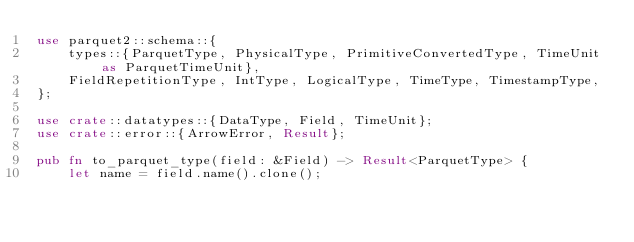Convert code to text. <code><loc_0><loc_0><loc_500><loc_500><_Rust_>use parquet2::schema::{
    types::{ParquetType, PhysicalType, PrimitiveConvertedType, TimeUnit as ParquetTimeUnit},
    FieldRepetitionType, IntType, LogicalType, TimeType, TimestampType,
};

use crate::datatypes::{DataType, Field, TimeUnit};
use crate::error::{ArrowError, Result};

pub fn to_parquet_type(field: &Field) -> Result<ParquetType> {
    let name = field.name().clone();</code> 